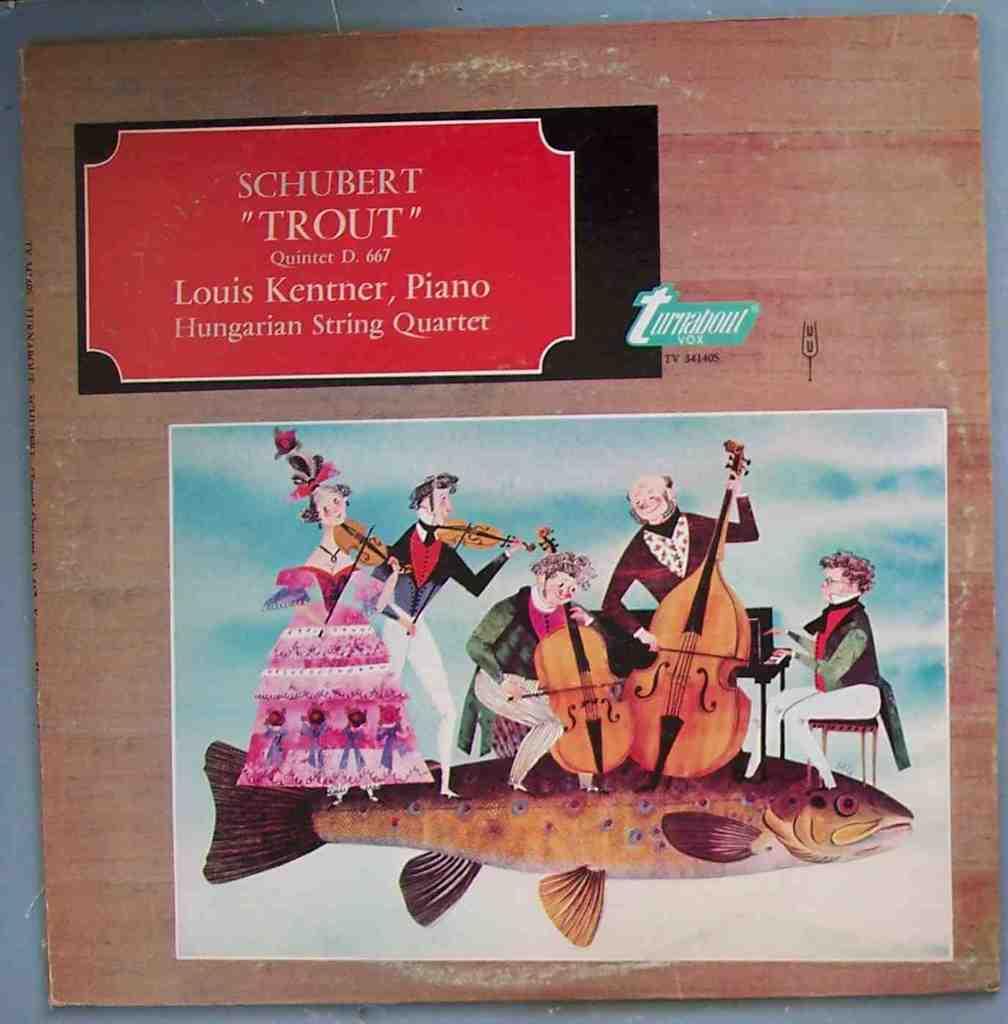What kind of fish is shown here?
Provide a short and direct response. Trout. What type of piano is it?
Offer a terse response. Unanswerable. 